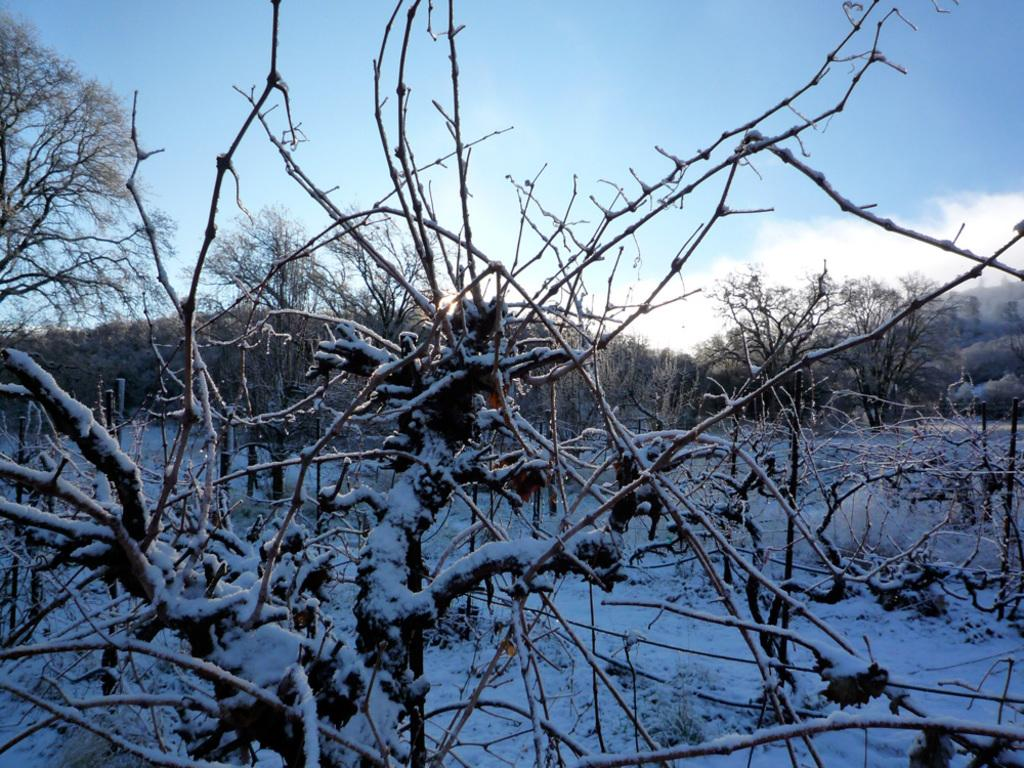What type of natural environment is depicted in the image? There are many trees and plants in the image, suggesting a forest or wooded area. What weather condition is present in the image? There is snow visible in the image, indicating a cold or wintery environment. How would you describe the sky in the image? The sky is blue and slightly cloudy in the image. What type of plantation can be seen in the image? There is no plantation present in the image; it features a natural environment with trees and plants. What color is the governor's skirt in the image? There is no governor or skirt present in the image. 